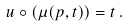Convert formula to latex. <formula><loc_0><loc_0><loc_500><loc_500>u \circ ( \mu ( p , t ) ) = t \, .</formula> 